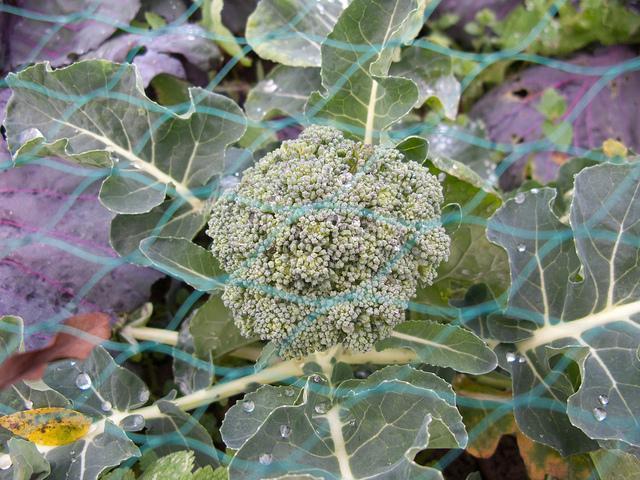How many broccolis are there?
Give a very brief answer. 1. 